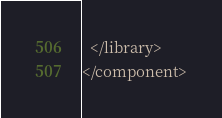<code> <loc_0><loc_0><loc_500><loc_500><_XML_>  </library>
</component>
</code> 